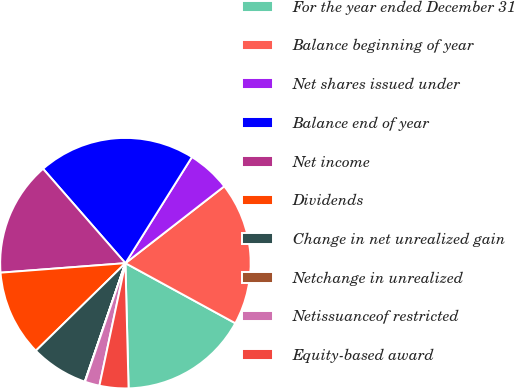<chart> <loc_0><loc_0><loc_500><loc_500><pie_chart><fcel>For the year ended December 31<fcel>Balance beginning of year<fcel>Net shares issued under<fcel>Balance end of year<fcel>Net income<fcel>Dividends<fcel>Change in net unrealized gain<fcel>Netchange in unrealized<fcel>Netissuanceof restricted<fcel>Equity-based award<nl><fcel>16.64%<fcel>18.48%<fcel>5.57%<fcel>20.33%<fcel>14.79%<fcel>11.11%<fcel>7.42%<fcel>0.04%<fcel>1.89%<fcel>3.73%<nl></chart> 